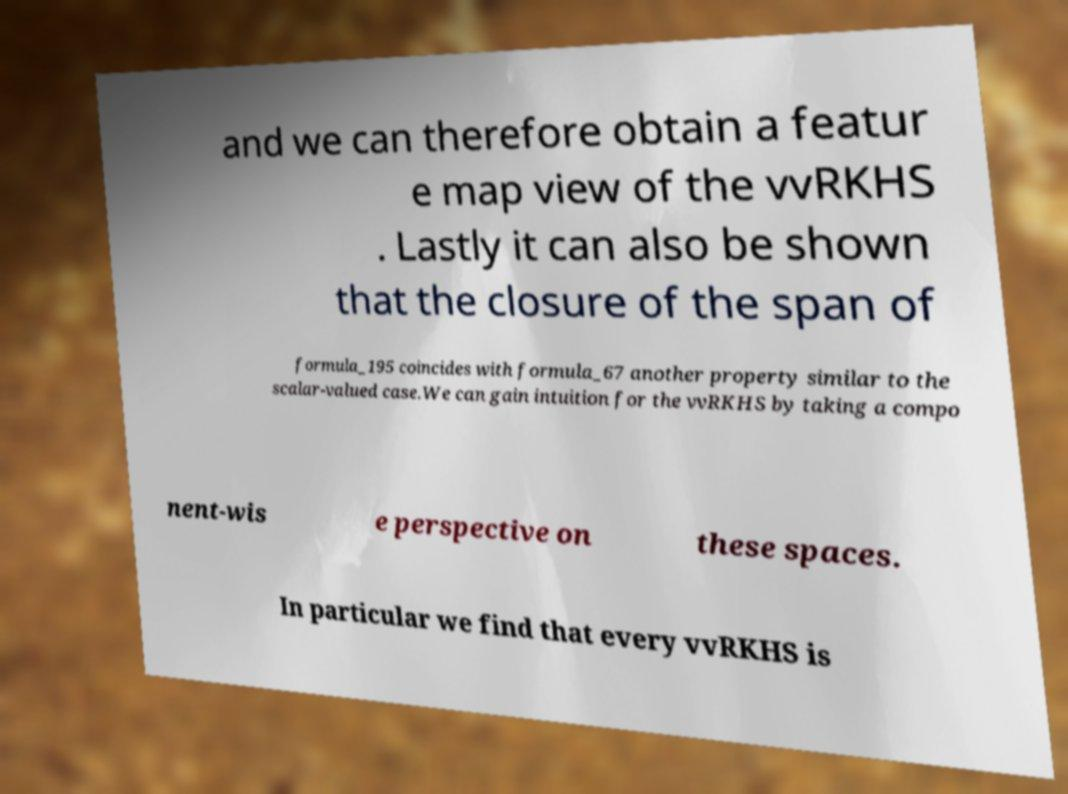What messages or text are displayed in this image? I need them in a readable, typed format. and we can therefore obtain a featur e map view of the vvRKHS . Lastly it can also be shown that the closure of the span of formula_195 coincides with formula_67 another property similar to the scalar-valued case.We can gain intuition for the vvRKHS by taking a compo nent-wis e perspective on these spaces. In particular we find that every vvRKHS is 